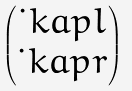Convert formula to latex. <formula><loc_0><loc_0><loc_500><loc_500>\begin{pmatrix} \dot { \ } k a p l \\ \dot { \ } k a p r \end{pmatrix}</formula> 